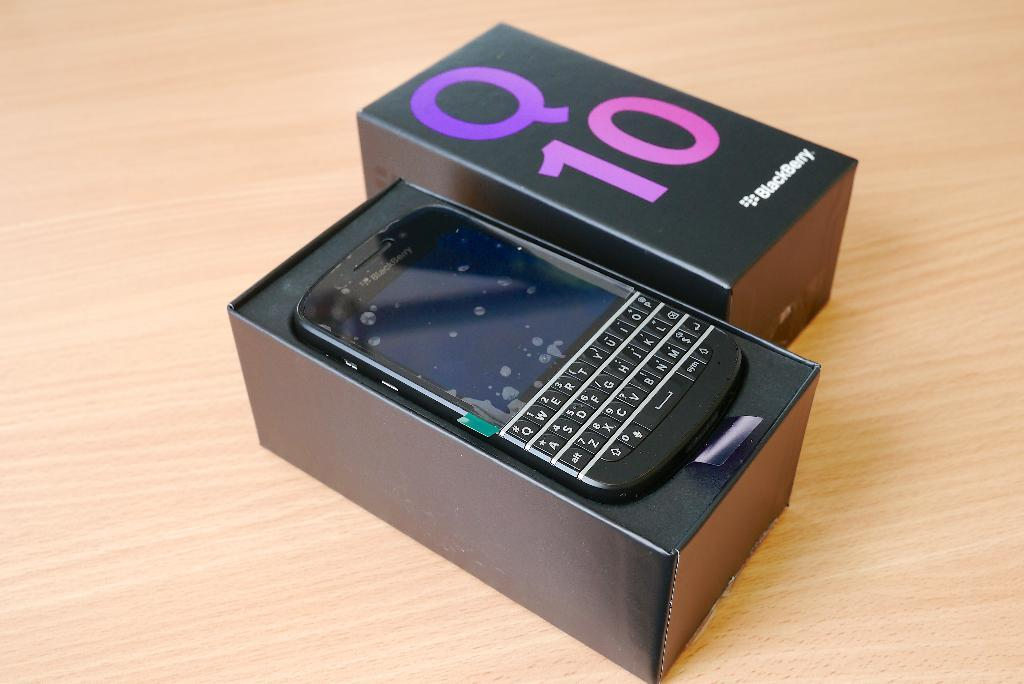<image>
Share a concise interpretation of the image provided. An opened black box displaying a Q 10 cellphone by BlackBerry 